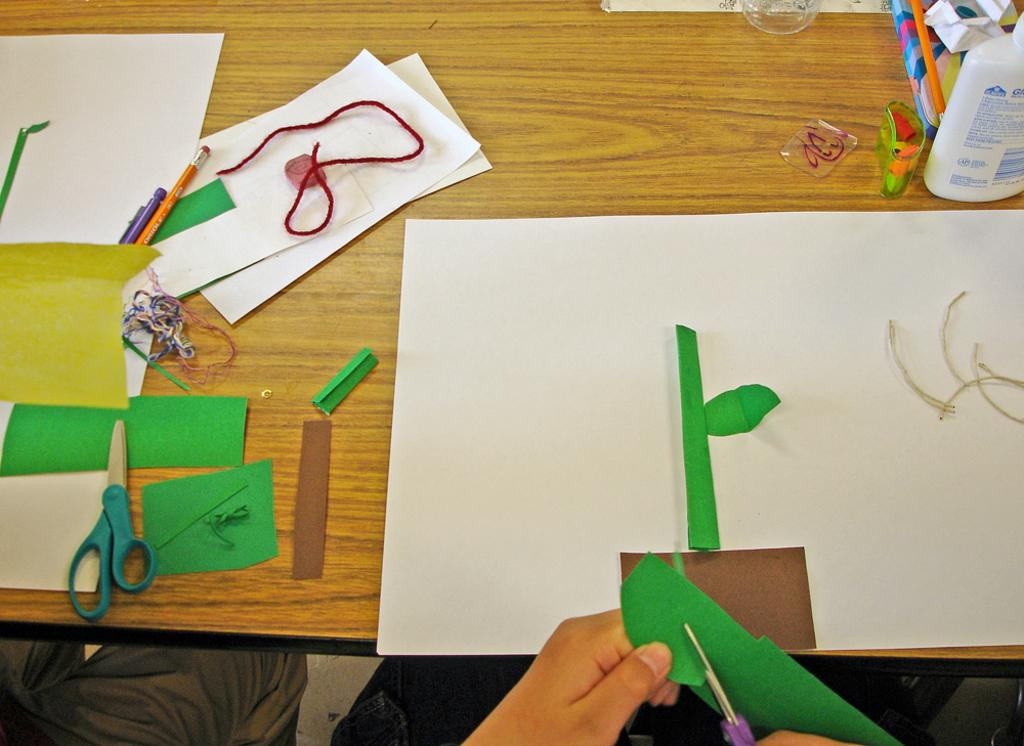What is located in the middle of the image? There is a table in the middle of the image. What items can be seen on the table? Papers, pens, pencils, scissors, a bottle, glasses, and threads are on the table. What might be used for writing or drawing on the papers? Pens and pencils are on the table for writing or drawing. What might be used for cutting the papers? Scissors are on the table for cutting the papers. What might be used for holding liquids on the table? The bottle and glasses are on the table for holding liquids. Who is present in the image? There are people at the bottom of the image. What type of sofa can be seen in the image? There is no sofa present in the image. What is the starting point for the spring season in the image? The image does not depict a season or a starting point for any season. 